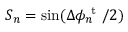<formula> <loc_0><loc_0><loc_500><loc_500>S _ { n } = \sin ( \Delta \phi _ { n } ^ { t } / 2 )</formula> 